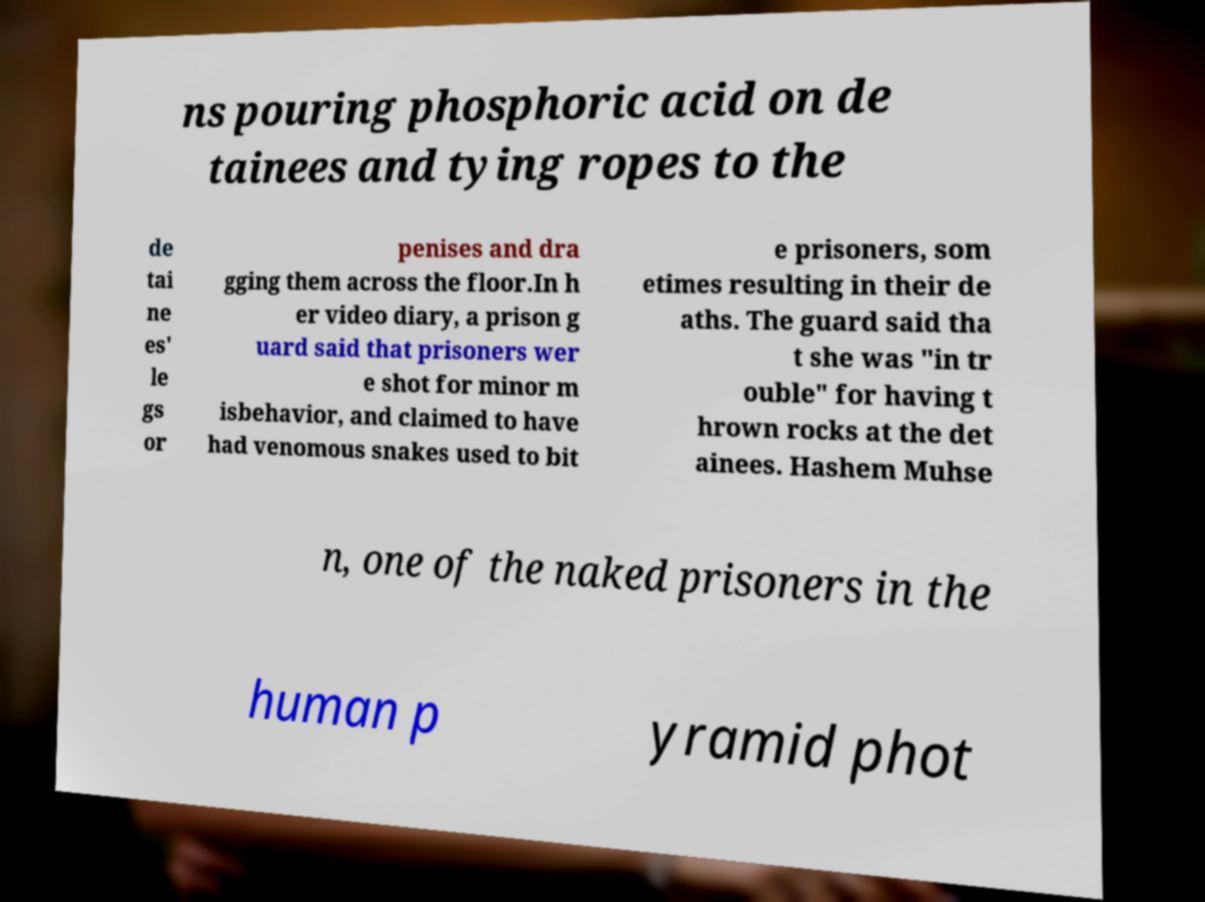I need the written content from this picture converted into text. Can you do that? ns pouring phosphoric acid on de tainees and tying ropes to the de tai ne es' le gs or penises and dra gging them across the floor.In h er video diary, a prison g uard said that prisoners wer e shot for minor m isbehavior, and claimed to have had venomous snakes used to bit e prisoners, som etimes resulting in their de aths. The guard said tha t she was "in tr ouble" for having t hrown rocks at the det ainees. Hashem Muhse n, one of the naked prisoners in the human p yramid phot 